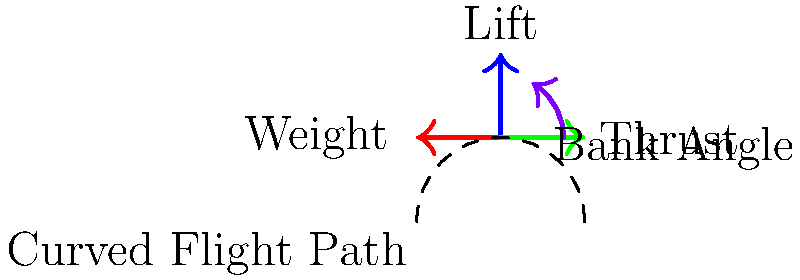During a banked turn, an aircraft experiences several force vectors. If the bank angle is 30°, the aircraft's weight is 15,000 lbs, and the turn is coordinated, what is the magnitude of the lift force required to maintain level flight? To solve this problem, we need to follow these steps:

1. Understand the forces acting on the aircraft:
   - Weight (W): Acts vertically downward
   - Lift (L): Acts perpendicular to the wings
   - Thrust and Drag: Assumed to be balanced in this scenario

2. In a coordinated turn, the vertical component of lift must equal the weight to maintain level flight.

3. The relationship between lift and weight in a banked turn is given by:

   $$ L = \frac{W}{\cos\theta} $$

   Where:
   $L$ = Lift force
   $W$ = Weight of the aircraft
   $\theta$ = Bank angle

4. Given:
   - Weight (W) = 15,000 lbs
   - Bank angle ($\theta$) = 30°

5. Plug the values into the equation:

   $$ L = \frac{15,000}{\cos 30°} $$

6. Calculate:
   $\cos 30° \approx 0.866$

   $$ L = \frac{15,000}{0.866} \approx 17,321 \text{ lbs} $$

Therefore, the lift force required to maintain level flight in this banked turn is approximately 17,321 lbs.
Answer: 17,321 lbs 